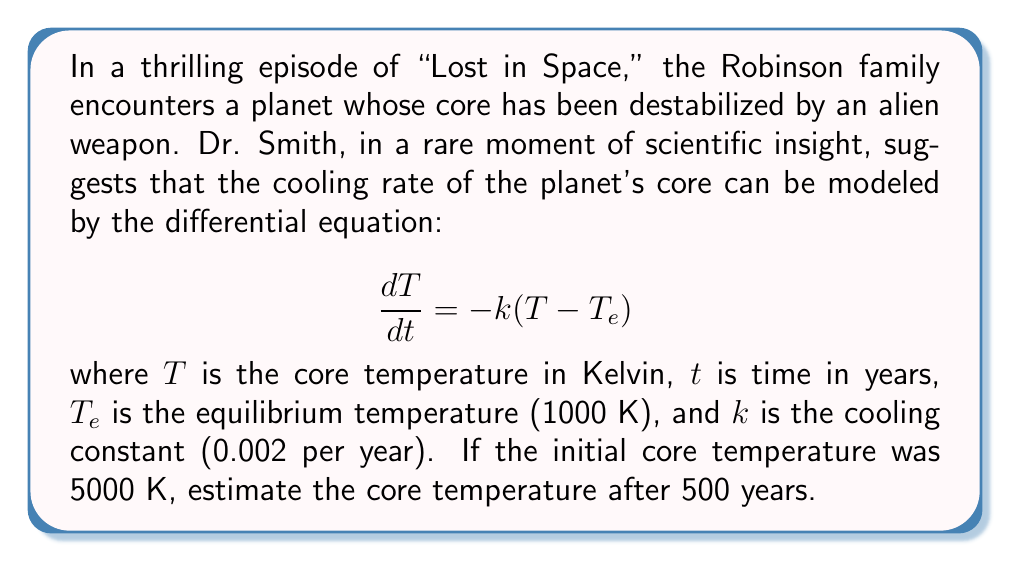Help me with this question. To solve this problem, we need to use the method for solving first-order linear differential equations. Let's approach this step-by-step:

1) The general form of the solution for this type of differential equation is:

   $$T(t) = T_e + (T_0 - T_e)e^{-kt}$$

   where $T_0$ is the initial temperature.

2) We are given:
   - $T_e = 1000$ K
   - $k = 0.002$ per year
   - $T_0 = 5000$ K
   - $t = 500$ years

3) Let's substitute these values into our solution:

   $$T(500) = 1000 + (5000 - 1000)e^{-0.002 \cdot 500}$$

4) Simplify:
   $$T(500) = 1000 + 4000e^{-1}$$

5) Calculate $e^{-1}$:
   $$T(500) = 1000 + 4000 \cdot 0.3679$$

6) Finish the calculation:
   $$T(500) = 1000 + 1471.6 = 2471.6$$

Therefore, after 500 years, the core temperature will be approximately 2471.6 K.
Answer: $2471.6$ K 